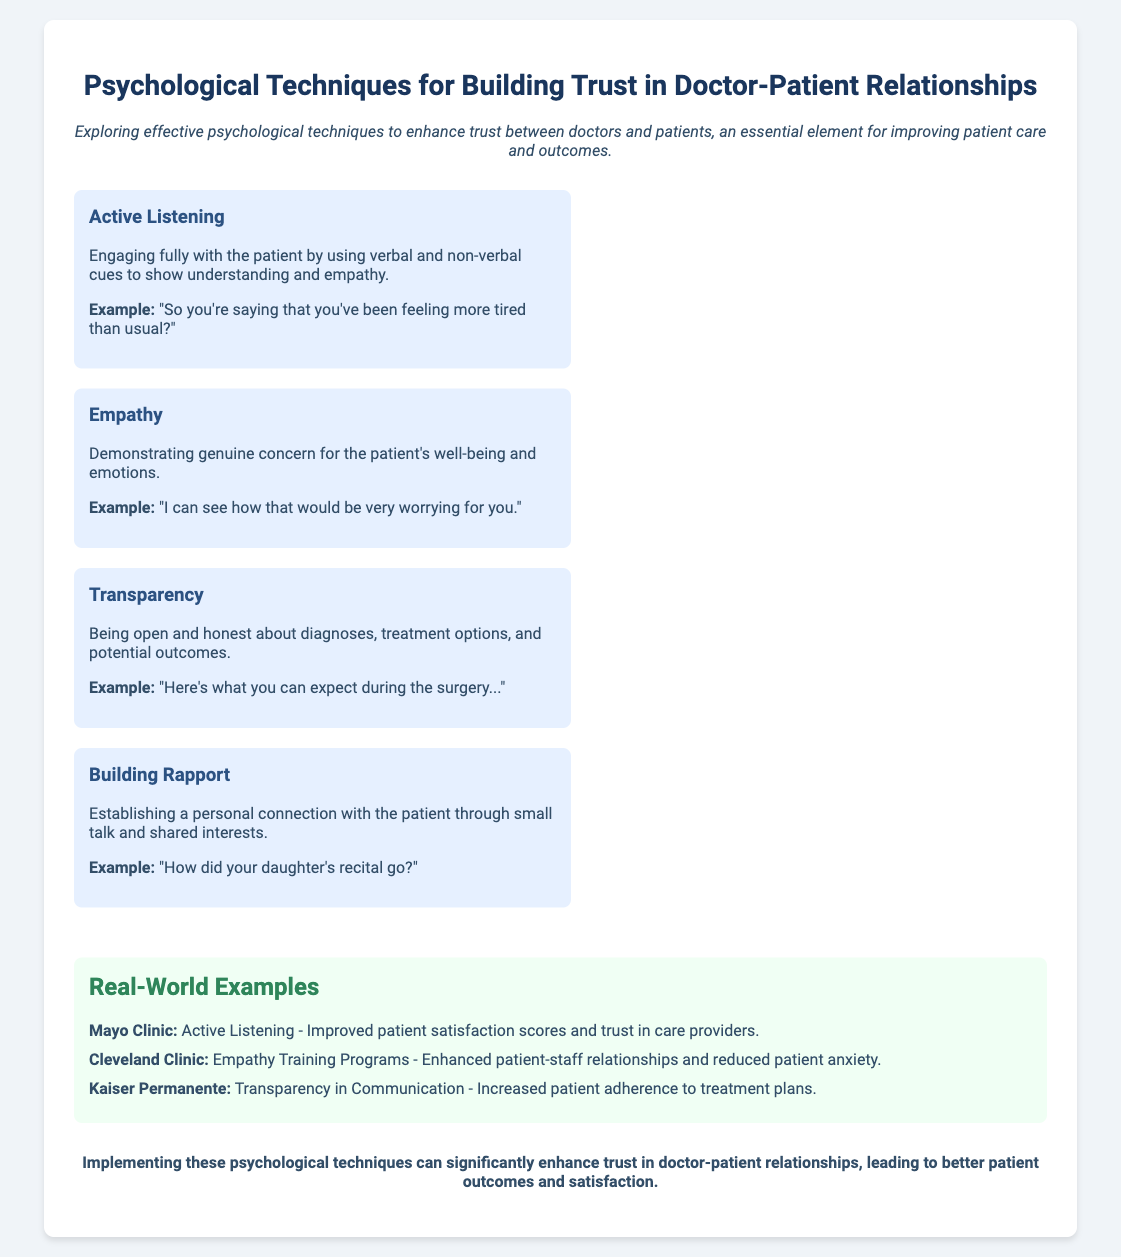What is the main topic of the presentation? The main topic is explicitly mentioned in the title of the slide.
Answer: Psychological Techniques for Building Trust in Doctor-Patient Relationships What psychological technique involves actively engaging with patients? This technique is described in the section discussing techniques and emphasizes the importance of engagement.
Answer: Active Listening Which healthcare facility implemented empathy training programs? The document mentions specific clinics that have adopted various techniques, including this one.
Answer: Cleveland Clinic What is the outcome of using transparency in communication according to Kaiser Permanente? The specific effect of transparency mentioned in the document highlights one measurable outcome of the technique.
Answer: Increased patient adherence to treatment plans In which technique can a doctor ask about a patient's family event? This detail relates directly to the technique that encourages establishing personal connections.
Answer: Building Rapport How does Mayo Clinic improve patient satisfaction according to the slide? The document provides an example where the focus is on active listening to improve patient relations.
Answer: Active Listening What kind of connection does building rapport foster? The answer is derived from the description of how rapport is established and its significance in relationships.
Answer: Personal connection What is a key benefit mentioned for implementing the psychological techniques? The conclusion summarizes the overall impact of the aforementioned techniques on patient care.
Answer: Better patient outcomes and satisfaction 